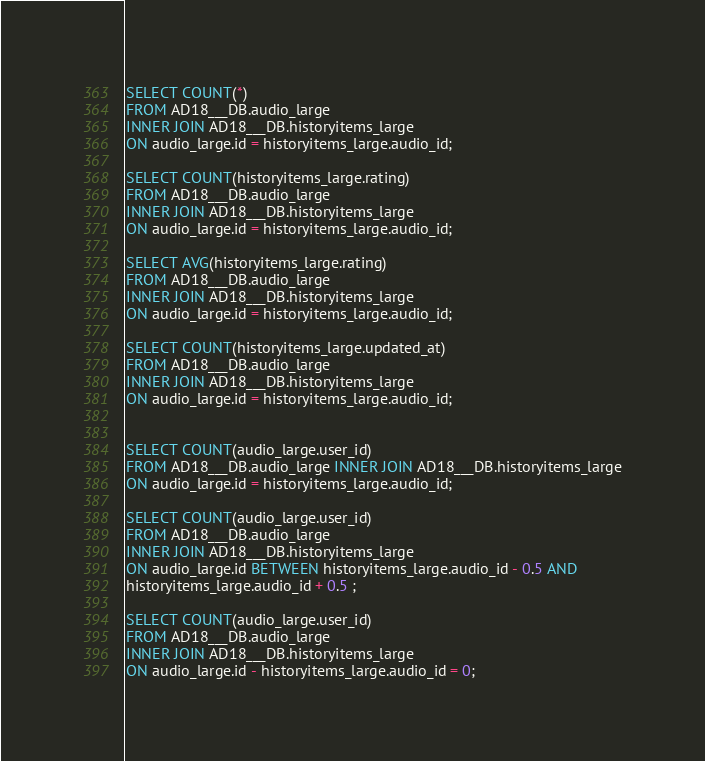Convert code to text. <code><loc_0><loc_0><loc_500><loc_500><_SQL_>SELECT COUNT(*)
FROM AD18___DB.audio_large
INNER JOIN AD18___DB.historyitems_large
ON audio_large.id = historyitems_large.audio_id;

SELECT COUNT(historyitems_large.rating)
FROM AD18___DB.audio_large
INNER JOIN AD18___DB.historyitems_large
ON audio_large.id = historyitems_large.audio_id;

SELECT AVG(historyitems_large.rating)
FROM AD18___DB.audio_large
INNER JOIN AD18___DB.historyitems_large
ON audio_large.id = historyitems_large.audio_id;

SELECT COUNT(historyitems_large.updated_at)
FROM AD18___DB.audio_large
INNER JOIN AD18___DB.historyitems_large
ON audio_large.id = historyitems_large.audio_id;


SELECT COUNT(audio_large.user_id)
FROM AD18___DB.audio_large INNER JOIN AD18___DB.historyitems_large
ON audio_large.id = historyitems_large.audio_id;

SELECT COUNT(audio_large.user_id)
FROM AD18___DB.audio_large
INNER JOIN AD18___DB.historyitems_large
ON audio_large.id BETWEEN historyitems_large.audio_id - 0.5 AND
historyitems_large.audio_id + 0.5 ;

SELECT COUNT(audio_large.user_id)
FROM AD18___DB.audio_large
INNER JOIN AD18___DB.historyitems_large
ON audio_large.id - historyitems_large.audio_id = 0;</code> 